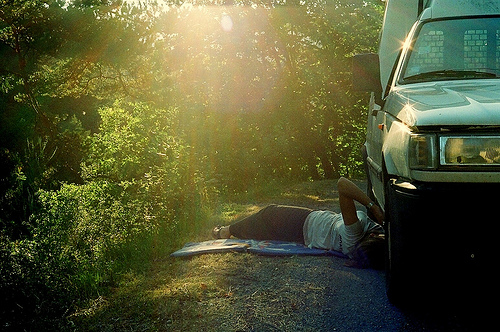<image>
Can you confirm if the car is behind the person? No. The car is not behind the person. From this viewpoint, the car appears to be positioned elsewhere in the scene. 